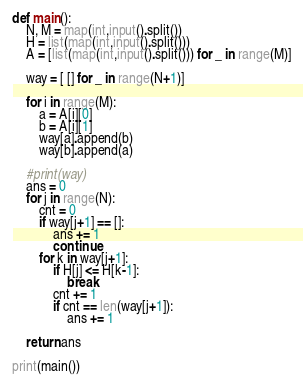Convert code to text. <code><loc_0><loc_0><loc_500><loc_500><_Python_>def main():
    N, M = map(int,input().split())
    H = list(map(int,input().split()))
    A = [list(map(int,input().split())) for _ in range(M)]

    way = [ [] for _ in range(N+1)]

    for i in range(M):
        a = A[i][0]
        b = A[i][1]
        way[a].append(b)
        way[b].append(a)

    #print(way)
    ans = 0
    for j in range(N):
        cnt = 0
        if way[j+1] == []:
            ans += 1
            continue
        for k in way[j+1]:
            if H[j] <= H[k-1]:
                break
            cnt += 1
            if cnt == len(way[j+1]):
                ans += 1

    return ans

print(main())
</code> 